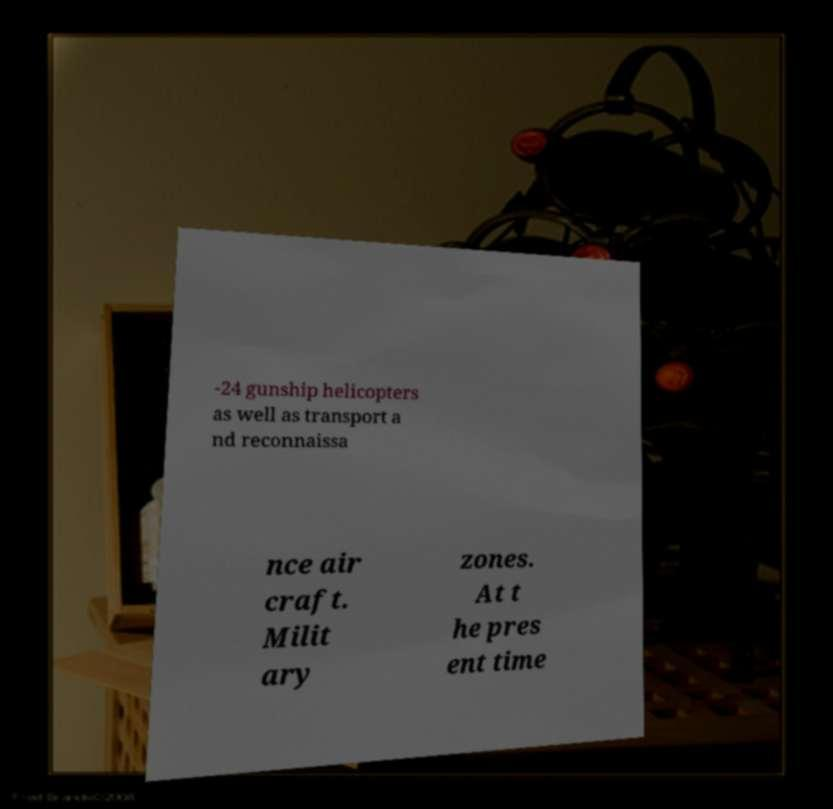I need the written content from this picture converted into text. Can you do that? -24 gunship helicopters as well as transport a nd reconnaissa nce air craft. Milit ary zones. At t he pres ent time 